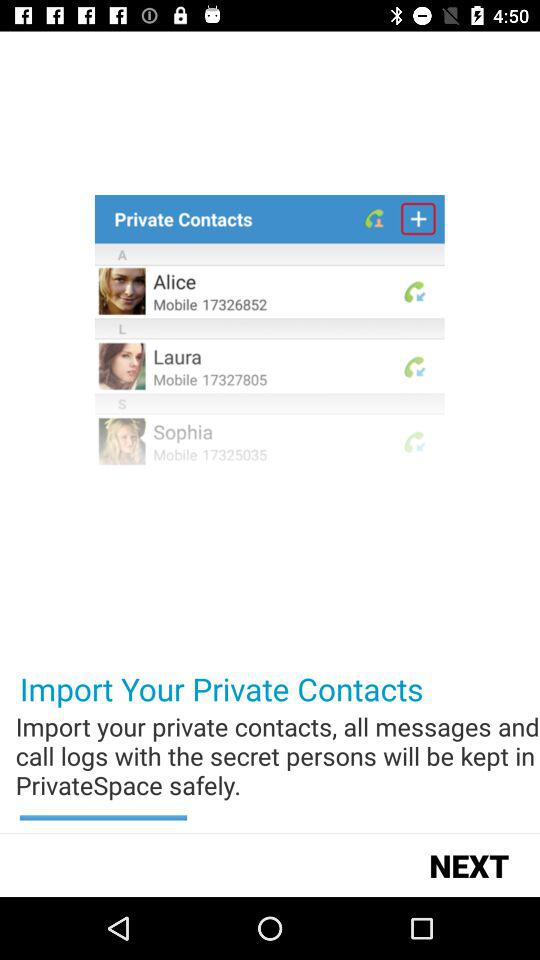How many people have the mobile number 173250535?
Answer the question using a single word or phrase. 1 